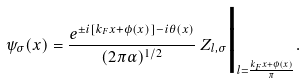<formula> <loc_0><loc_0><loc_500><loc_500>\psi _ { \sigma } ( x ) = \frac { e ^ { \pm i [ k _ { F } x + \phi ( x ) ] - i \theta ( x ) } } { ( 2 \pi \alpha ) ^ { 1 / 2 } } \, Z _ { l , \sigma } \Big | _ { l = \frac { k _ { F } x + \phi ( x ) } { \pi } } .</formula> 